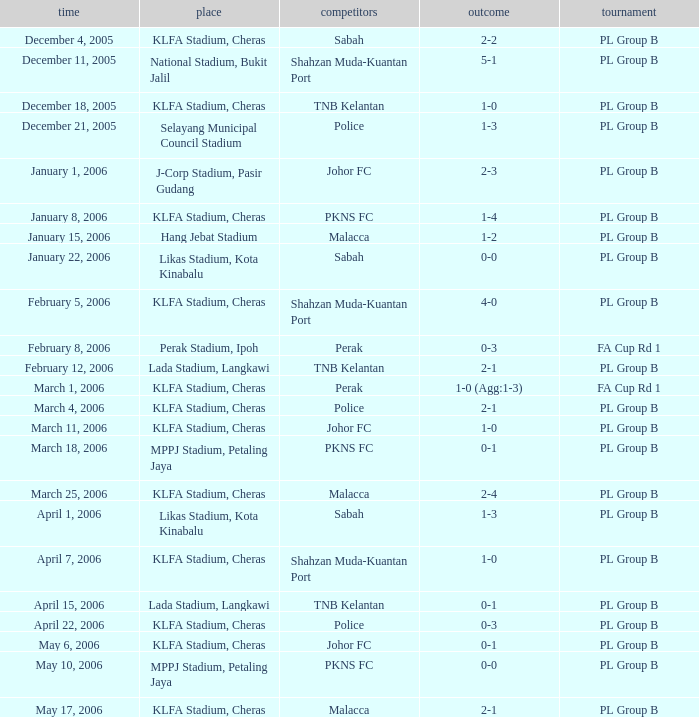Which Venue has a Competition of pl group b, and a Score of 2-2? KLFA Stadium, Cheras. 